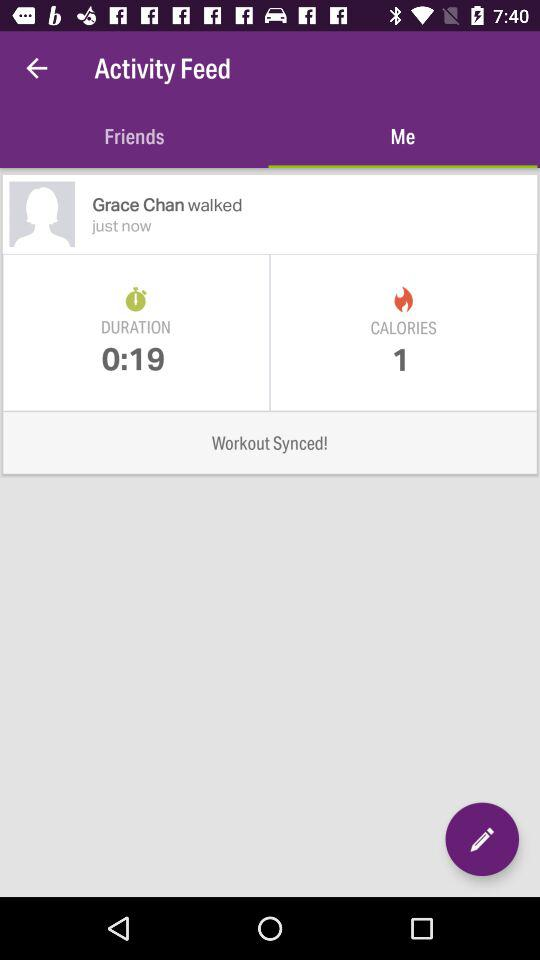How long ago did Grace Chan walk?
Answer the question using a single word or phrase. Just now 